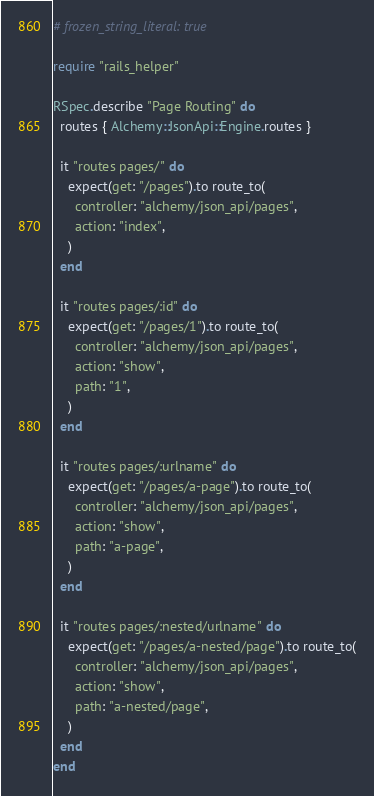<code> <loc_0><loc_0><loc_500><loc_500><_Ruby_># frozen_string_literal: true

require "rails_helper"

RSpec.describe "Page Routing" do
  routes { Alchemy::JsonApi::Engine.routes }

  it "routes pages/" do
    expect(get: "/pages").to route_to(
      controller: "alchemy/json_api/pages",
      action: "index",
    )
  end

  it "routes pages/:id" do
    expect(get: "/pages/1").to route_to(
      controller: "alchemy/json_api/pages",
      action: "show",
      path: "1",
    )
  end

  it "routes pages/:urlname" do
    expect(get: "/pages/a-page").to route_to(
      controller: "alchemy/json_api/pages",
      action: "show",
      path: "a-page",
    )
  end

  it "routes pages/:nested/urlname" do
    expect(get: "/pages/a-nested/page").to route_to(
      controller: "alchemy/json_api/pages",
      action: "show",
      path: "a-nested/page",
    )
  end
end
</code> 